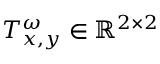<formula> <loc_0><loc_0><loc_500><loc_500>T _ { x , y } ^ { \omega } \in \mathbb { R } ^ { 2 \times 2 }</formula> 